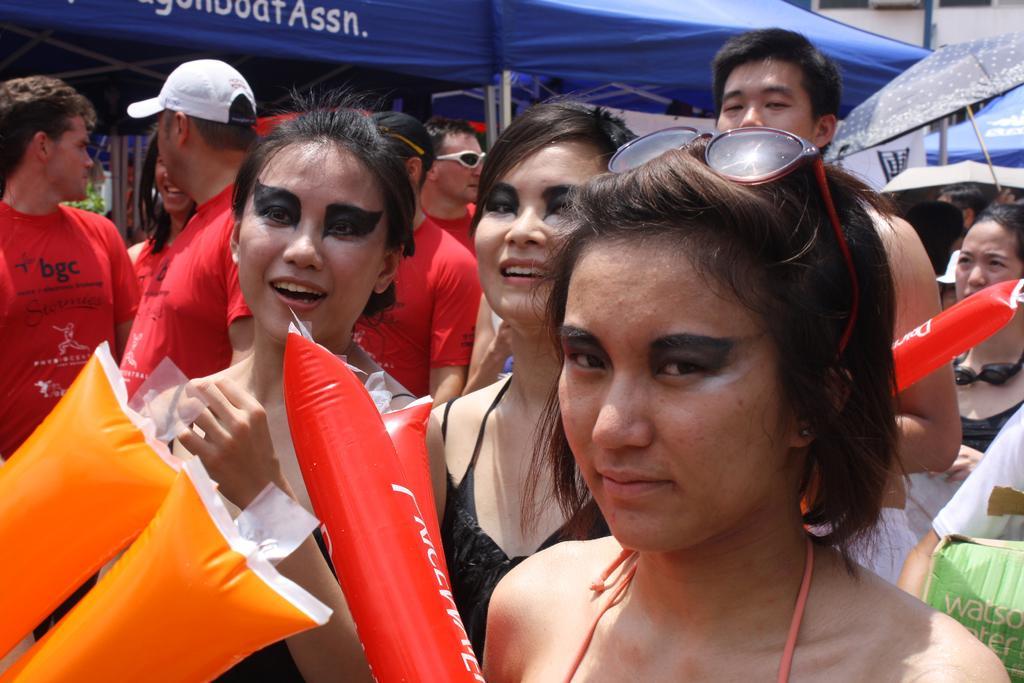Can you describe this image briefly? In the middle of the image few people are standing and holding some balloons. Behind them there are some tents. 